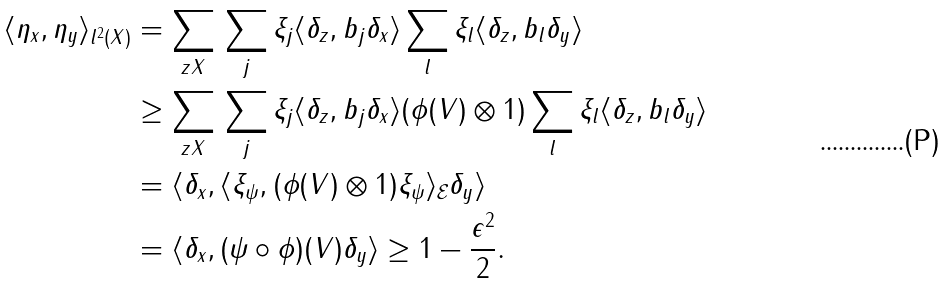Convert formula to latex. <formula><loc_0><loc_0><loc_500><loc_500>\langle \eta _ { x } , \eta _ { y } \rangle _ { l ^ { 2 } ( X ) } & = \sum _ { z X } \| \sum _ { j } \xi _ { j } \langle \delta _ { z } , b _ { j } \delta _ { x } \rangle \| \| \sum _ { l } \xi _ { l } \langle \delta _ { z } , b _ { l } \delta _ { y } \rangle \| \\ & \geq \sum _ { z X } \| \sum _ { j } \xi _ { j } \langle \delta _ { z } , b _ { j } \delta _ { x } \rangle \| \| ( \phi ( V ) \otimes 1 ) \sum _ { l } \xi _ { l } \langle \delta _ { z } , b _ { l } \delta _ { y } \rangle \| \\ & = \langle \delta _ { x } , \langle \xi _ { \psi } , ( \phi ( V ) \otimes 1 ) \xi _ { \psi } \rangle _ { \mathcal { E } } \delta _ { y } \rangle \\ & = \langle \delta _ { x } , ( \psi \circ \phi ) ( V ) \delta _ { y } \rangle \geq 1 - \frac { \epsilon ^ { 2 } } { 2 } .</formula> 